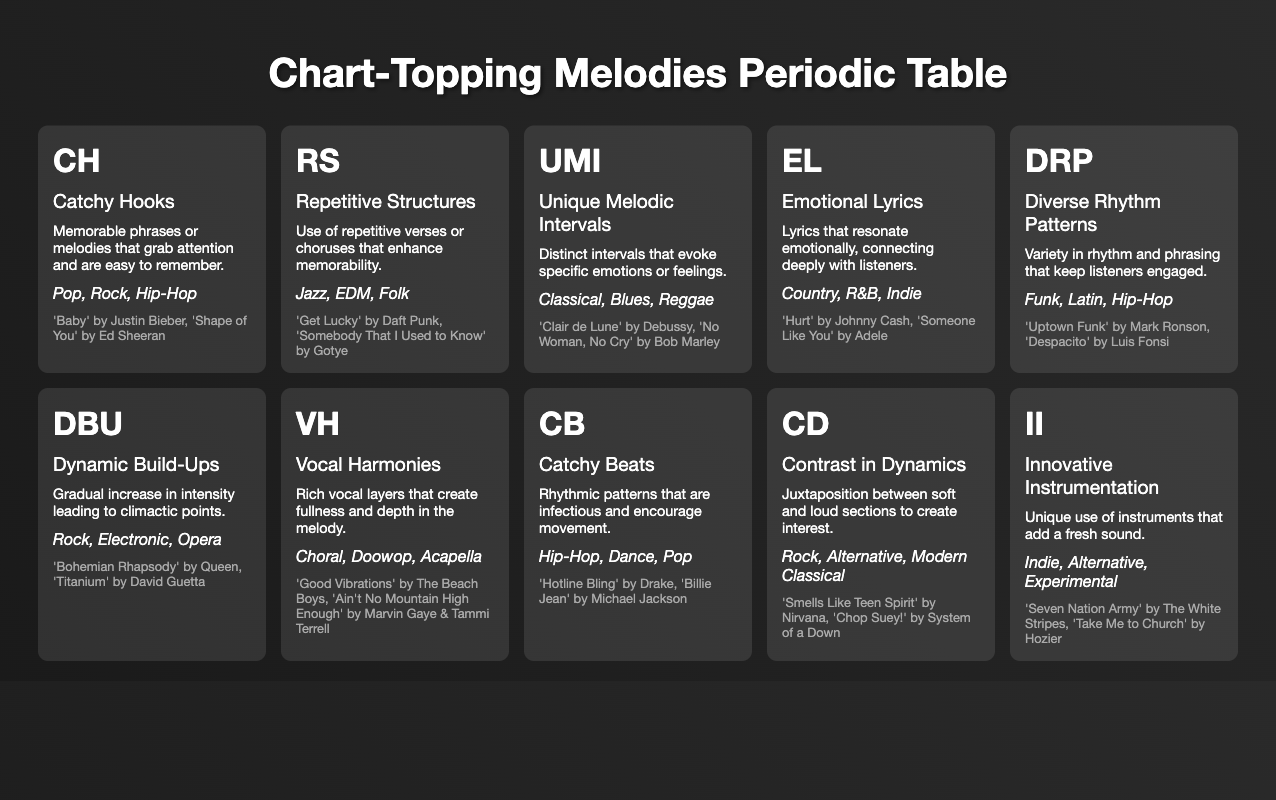What genres utilize Catchy Hooks? The table lists the genres associated with Catchy Hooks as Pop, Rock, and Hip-Hop. By reviewing the elements' genre lists directly under the Catchy Hooks section, we can quickly identify these genres.
Answer: Pop, Rock, Hip-Hop Which element is associated with Emotional Lyrics? The table directly indicates that the element associated with Emotional Lyrics is EL. Referring to the description, we can confirm that the element specifically correlates with the power of lyrics in Country, R&B, and Indie genres.
Answer: EL How many types of genres are represented for Unique Melodic Intervals? By examining the Unique Melodic Intervals row, we see the genres mentioned are Classical, Blues, and Reggae. Counting these genres gives us a total of three listed.
Answer: 3 Do the elements of Dynamic Build-Ups and Diverse Rhythm Patterns share any common genres? Looking at the genres for each element, Dynamic Build-Ups includes Rock, Electronic, and Opera, while Diverse Rhythm Patterns includes Funk, Latin, and Hip-Hop. None of the genres overlap, thus the answer is no.
Answer: No What is the most common attribute present in both Pop and Hip-Hop genres? The table shows Catchy Hooks and Catchy Beats as attributes associated with Pop and Hip-Hop. This indicates both genres share these two attributes based on their respective rows for the elements. Therefore, these attributes are common.
Answer: Catchy Hooks, Catchy Beats How many examples are listed under the Vocal Harmonies element? In the Vocal Harmonies section, there are two song examples provided, which are 'Good Vibrations' by The Beach Boys and 'Ain't No Mountain High Enough' by Marvin Gaye & Tammi Terrell. Hence, we count them for the final answer.
Answer: 2 If I review all the elements in the table, how many of them are primarily linked to songs from the Pop genre? After examining the elements, the ones connected to Pop are Catchy Hooks and Catchy Beats. Therefore, these two elements being linked specifically to songs from the Pop genre results in an answer.
Answer: 2 Which two elements with emotional appeal are categorized within genres related to Indie music? The elements Emotional Lyrics and Innovative Instrumentation are both associated with the Indie genre. By identifying the genres under both elements in the table, we confirm their relevance directly.
Answer: Emotional Lyrics, Innovative Instrumentation Is there an element that includes a genre listed which is neither Hip-Hop nor Pop? Analyzing the genres under each element, we find several attributes such as Unique Melodic Intervals and Emotional Lyrics that encompass genres like Classical and Country, respectively, neither of which are linked to Hip-Hop or Pop. Thus, the answer is yes.
Answer: Yes 